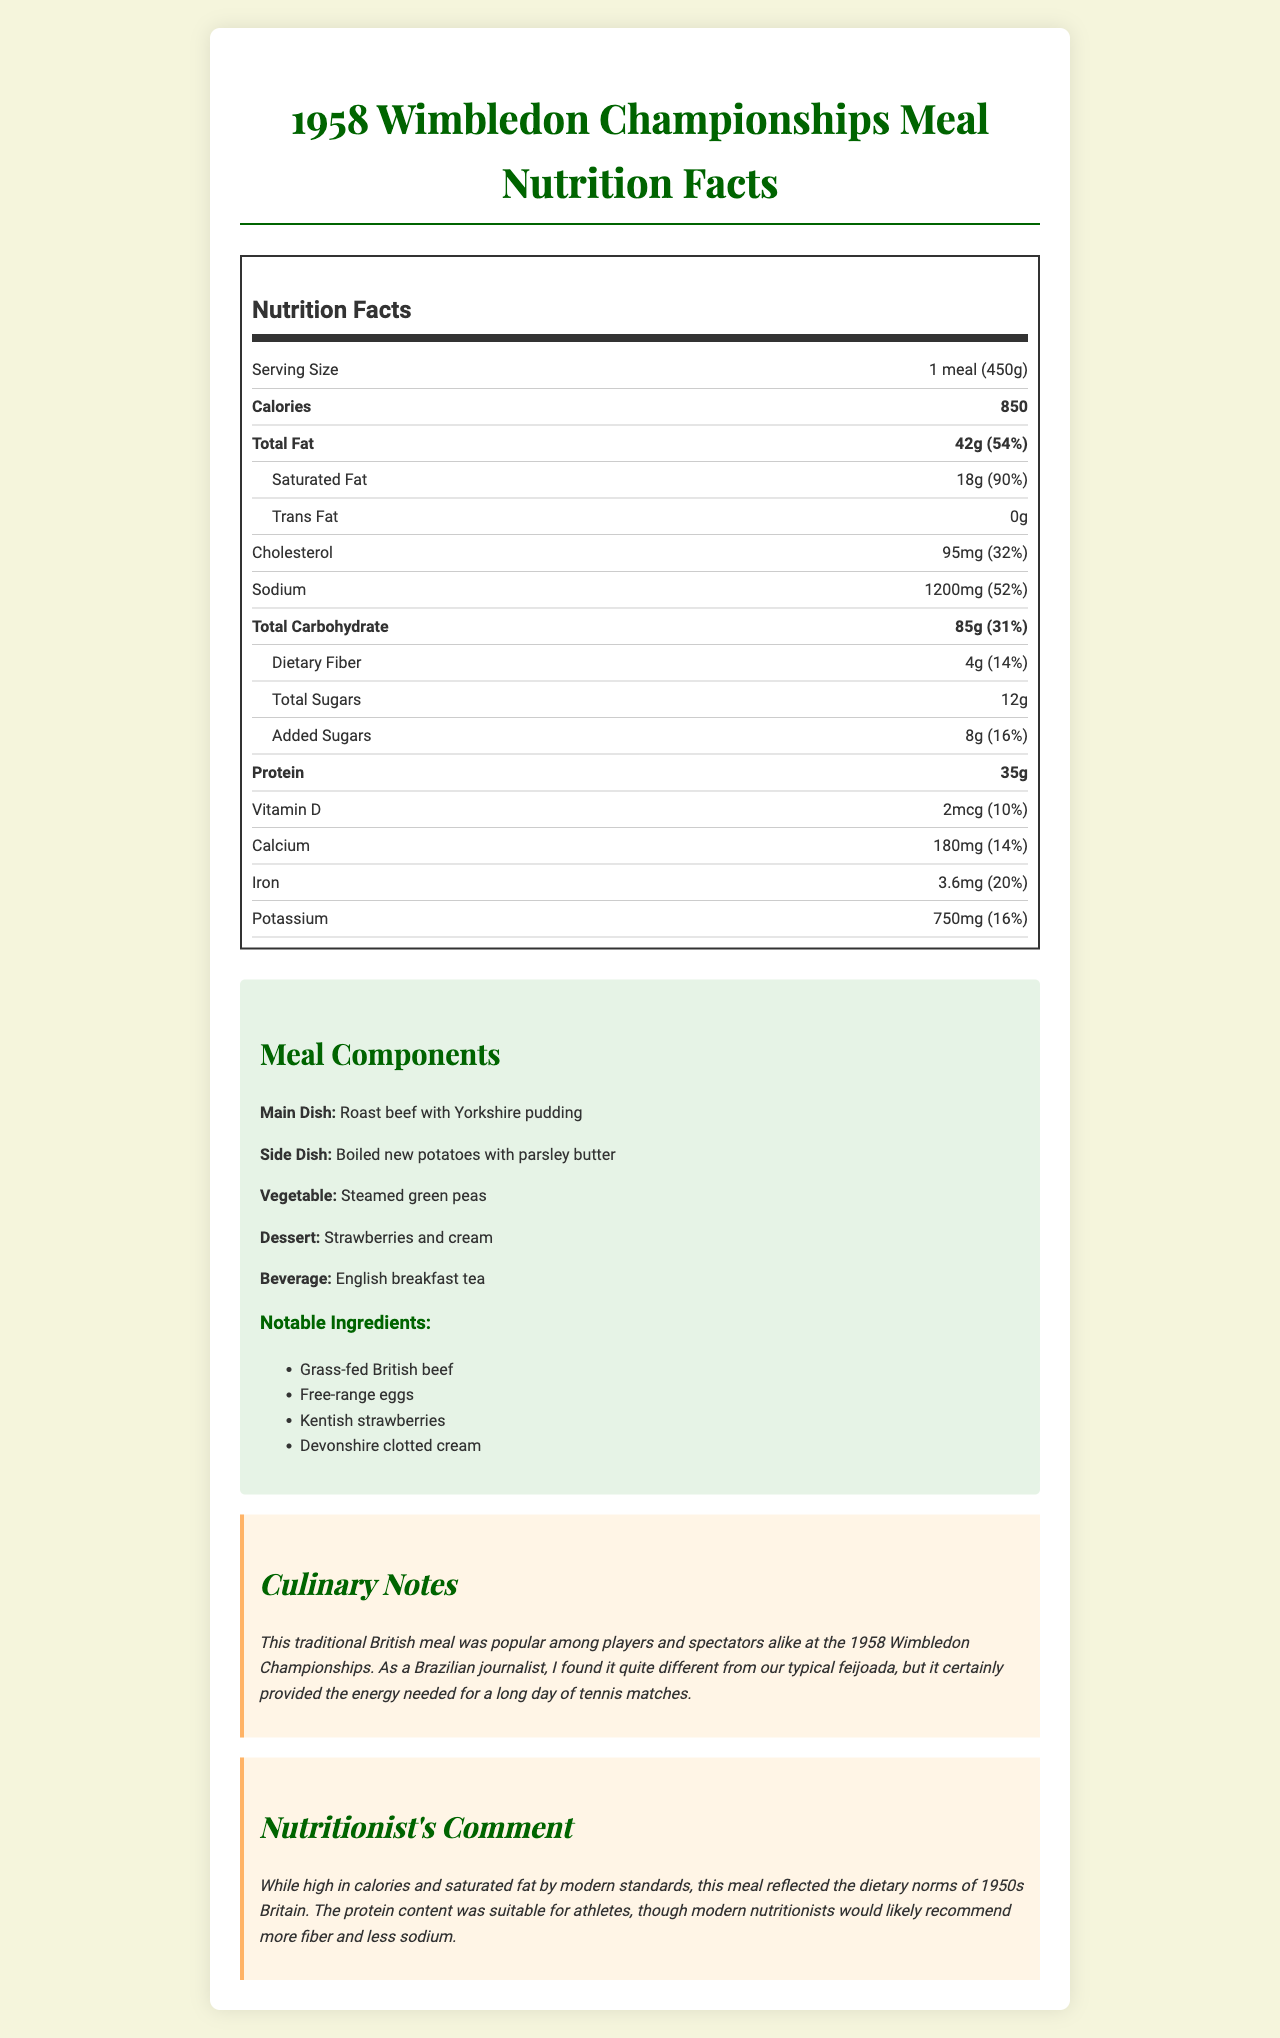what is the serving size? The serving size is displayed right under the "Nutrition Facts" heading and is listed as 1 meal (450g).
Answer: 1 meal (450g) how many calories are in one serving? The document lists the calorie content in bold as 850, right after the serving size.
Answer: 850 how much saturated fat does this meal contain? The amount of saturated fat is listed under the "Total Fat" entry, showing as 18g.
Answer: 18g how much sodium is in this meal? The sodium content is shown as 1200mg, which is highlighted under its own entry.
Answer: 1200mg how many total sugars are there? The total sugars amount is listed under the "Total Carbohydrate" section as 12g.
Answer: 12g which dish from the meal contains British beef? A. Main Dish B. Side Dish C. Dessert The main dish is identified as "Roast beef with Yorkshire pudding," which contains British beef.
Answer: A what is the percentage of daily value for protein in this meal? A. 14% B. 52% C. 70% D. 90% The percentage daily value for protein is shown as 70% next to the protein amount.
Answer: C does this meal contain any trans fats? The document specifies the trans fat amount as 0g, indicating that the meal does not contain trans fats.
Answer: No describe the main idea of the document The document elaborates on the nutritional content of the meal, breaks down its components, and offers additional notes on its cultural significance and a nutritionist's viewpoint.
Answer: The document provides detailed nutrition facts for a typical meal served at the 1958 Wimbledon Championships. It includes sections on serving size, calories, fat content, carbohydrate content, protein, and vitamins, along with meal components, notable ingredients, culinary notes, and a nutritionist's comment. how was the grass-fed beef sourced? The document does not specify how the grass-fed British beef was sourced, just that it was a notable ingredient.
Answer: Not enough information is this meal rich in fiber? The dietary fiber content is 4g, which is 14% of the daily value, indicating that the meal is not particularly rich in fiber.
Answer: No what are the notable ingredients in the meal? The notable ingredients are listed in their own section under "Notable Ingredients."
Answer: Grass-fed British beef, Free-range eggs, Kentish strawberries, Devonshire clotted cream what beverage was served with the meal? The beverage section clearly lists English breakfast tea as the accompanying drink.
Answer: English breakfast tea what was the vegetable served in the meal? The document identifies steamed green peas as the vegetable served with the meal.
Answer: Steamed green peas how many percent of daily value is the sodium content? The sodium content is listed as 1200mg, which corresponds to 52% of the daily value.
Answer: 52% what does the nutritionist comment on the meal? The nutritionist's comment section explains that although the meal was calorically and fat-dense, it was protein-rich, making it fit for athletes, albeit with a recommendation for more fiber and less sodium in modern times.
Answer: The meal was high in calories and saturated fat by modern standards but suitable for athletes due to its high protein content. Modern nutritionists would recommend more fiber and less sodium. 